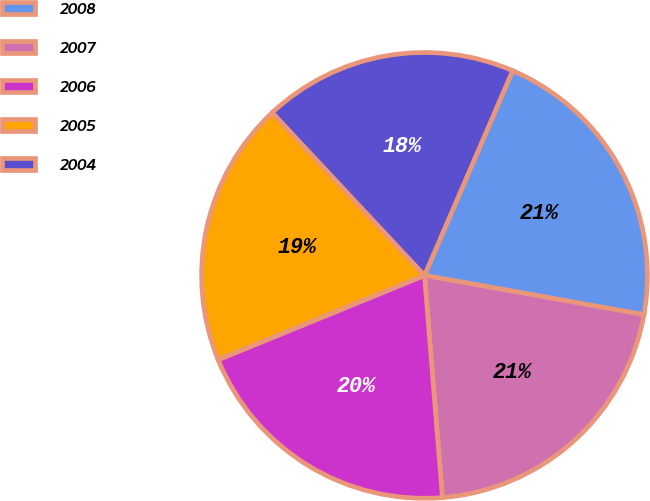Convert chart to OTSL. <chart><loc_0><loc_0><loc_500><loc_500><pie_chart><fcel>2008<fcel>2007<fcel>2006<fcel>2005<fcel>2004<nl><fcel>21.35%<fcel>20.9%<fcel>20.11%<fcel>19.21%<fcel>18.44%<nl></chart> 